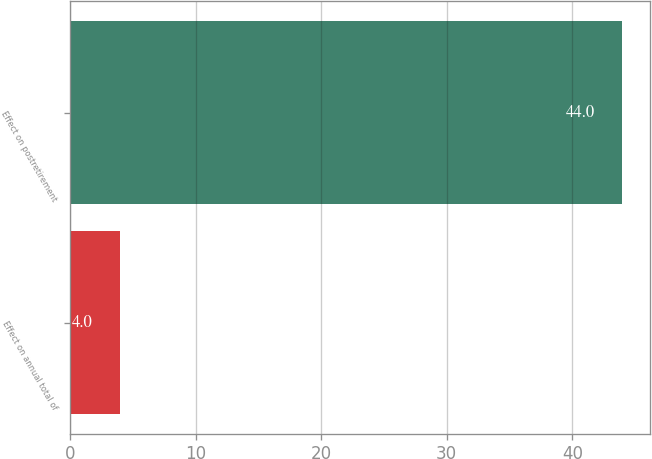Convert chart to OTSL. <chart><loc_0><loc_0><loc_500><loc_500><bar_chart><fcel>Effect on annual total of<fcel>Effect on postretirement<nl><fcel>4<fcel>44<nl></chart> 